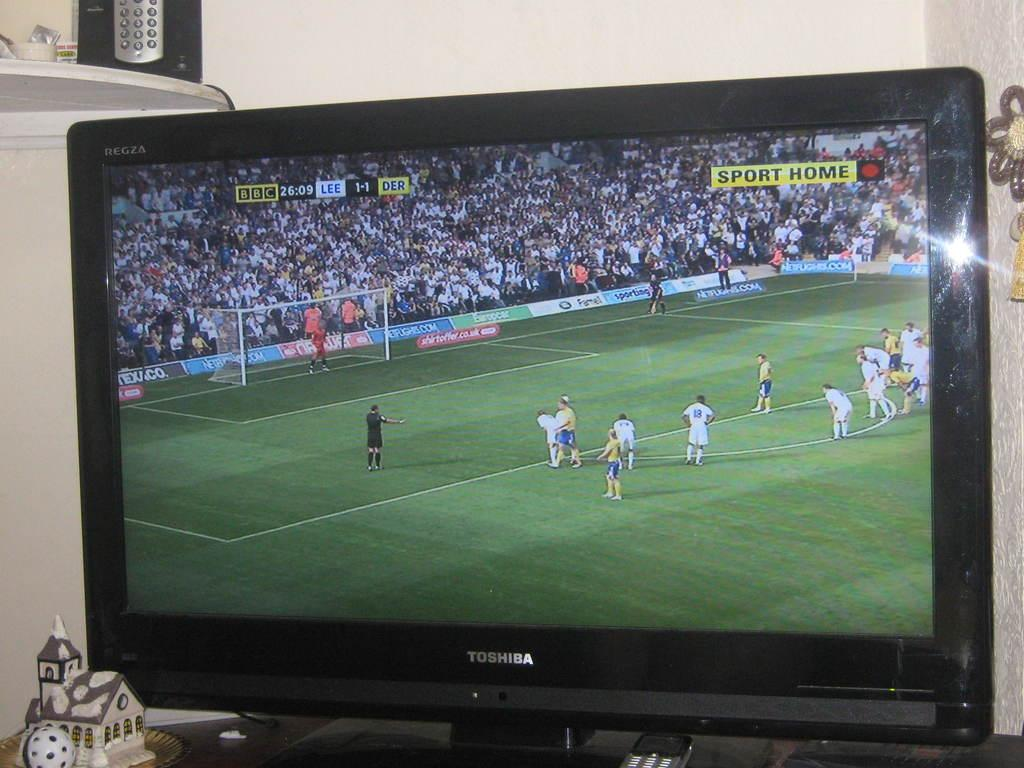<image>
Present a compact description of the photo's key features. A still shot of a TV screen shows a soccer game between LEE and DER at a 1-1 tie. 